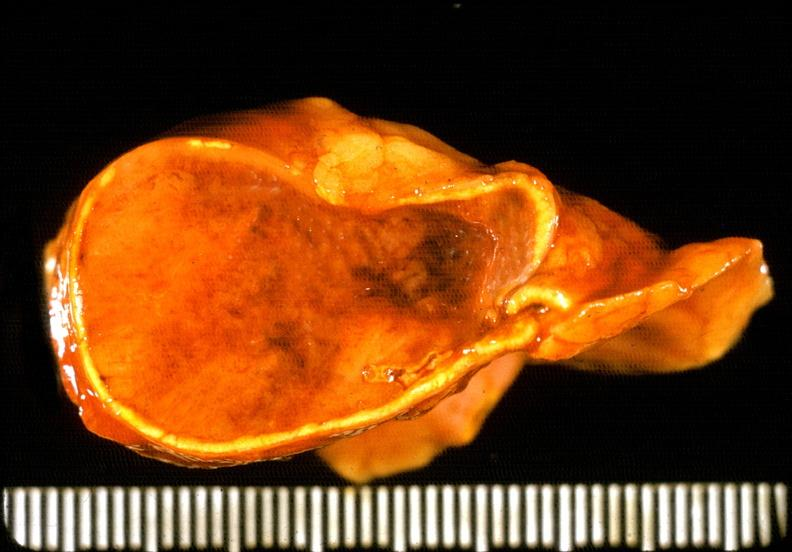does atherosclerosis show adrenal phaeochromocytoma?
Answer the question using a single word or phrase. No 